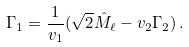Convert formula to latex. <formula><loc_0><loc_0><loc_500><loc_500>\Gamma _ { 1 } = \frac { 1 } { v _ { 1 } } ( \sqrt { 2 } \hat { M } _ { \ell } - v _ { 2 } \Gamma _ { 2 } ) \, .</formula> 